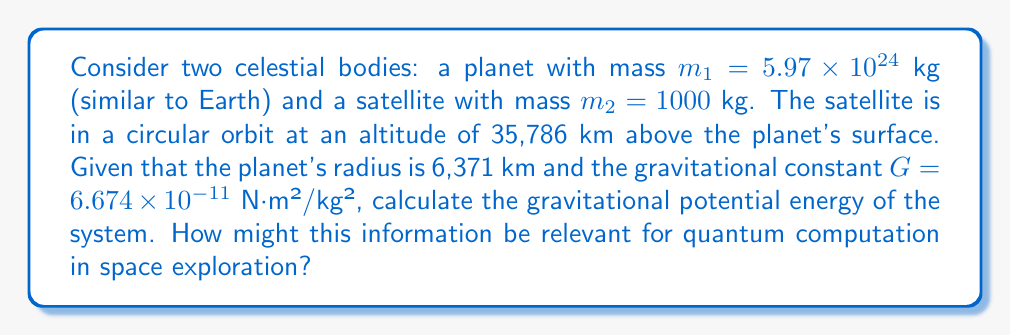What is the answer to this math problem? To solve this problem, we'll follow these steps:

1) First, let's recall the formula for gravitational potential energy between two masses:

   $$U = -\frac{GMm}{r}$$

   where $G$ is the gravitational constant, $M$ and $m$ are the masses of the two bodies, and $r$ is the distance between their centers.

2) We need to calculate $r$, which is the sum of the planet's radius and the satellite's altitude:

   $$r = 6,371 \text{ km} + 35,786 \text{ km} = 42,157 \text{ km} = 42,157,000 \text{ m}$$

3) Now, let's substitute all the values into the equation:

   $$U = -\frac{(6.674 \times 10^{-11})(5.97 \times 10^{24})(1000)}{42,157,000}$$

4) Simplify:

   $$U = -\frac{3.984378 \times 10^{17}}{42,157,000}$$

5) Calculate the final result:

   $$U = -9.45 \times 10^9 \text{ J}$$

The negative sign indicates that work needs to be done to separate the two bodies.

Regarding quantum computation in space exploration:
This energy calculation is crucial for orbit determination and satellite positioning. Quantum computers could potentially perform these calculations much faster and more accurately for multiple bodies simultaneously, enabling more precise predictions of orbital dynamics. This could be particularly useful for complex mission planning or for managing large satellite constellations.
Answer: The gravitational potential energy of the system is $-9.45 \times 10^9$ J. 